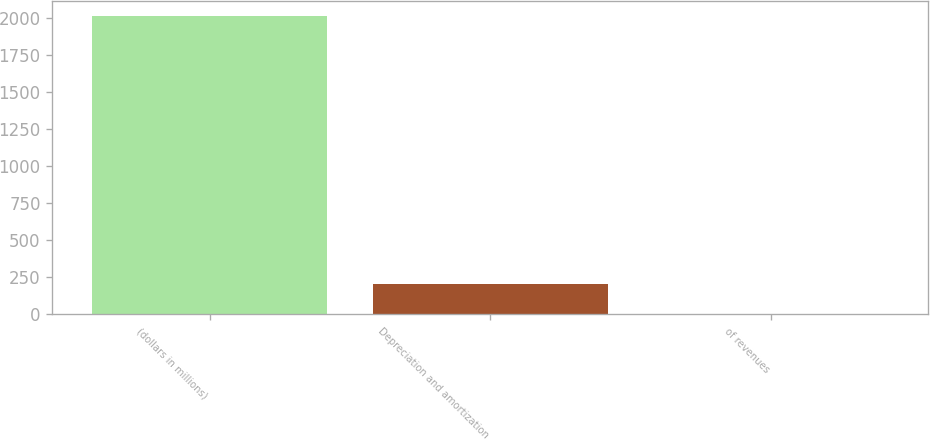Convert chart to OTSL. <chart><loc_0><loc_0><loc_500><loc_500><bar_chart><fcel>(dollars in millions)<fcel>Depreciation and amortization<fcel>of revenues<nl><fcel>2014<fcel>204.01<fcel>2.9<nl></chart> 